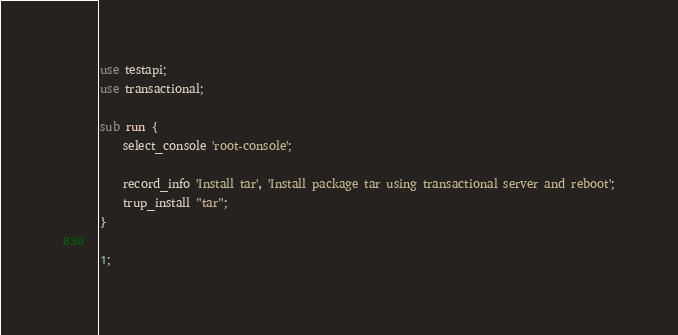<code> <loc_0><loc_0><loc_500><loc_500><_Perl_>use testapi;
use transactional;

sub run {
    select_console 'root-console';

    record_info 'Install tar', 'Install package tar using transactional server and reboot';
    trup_install "tar";
}

1;
</code> 